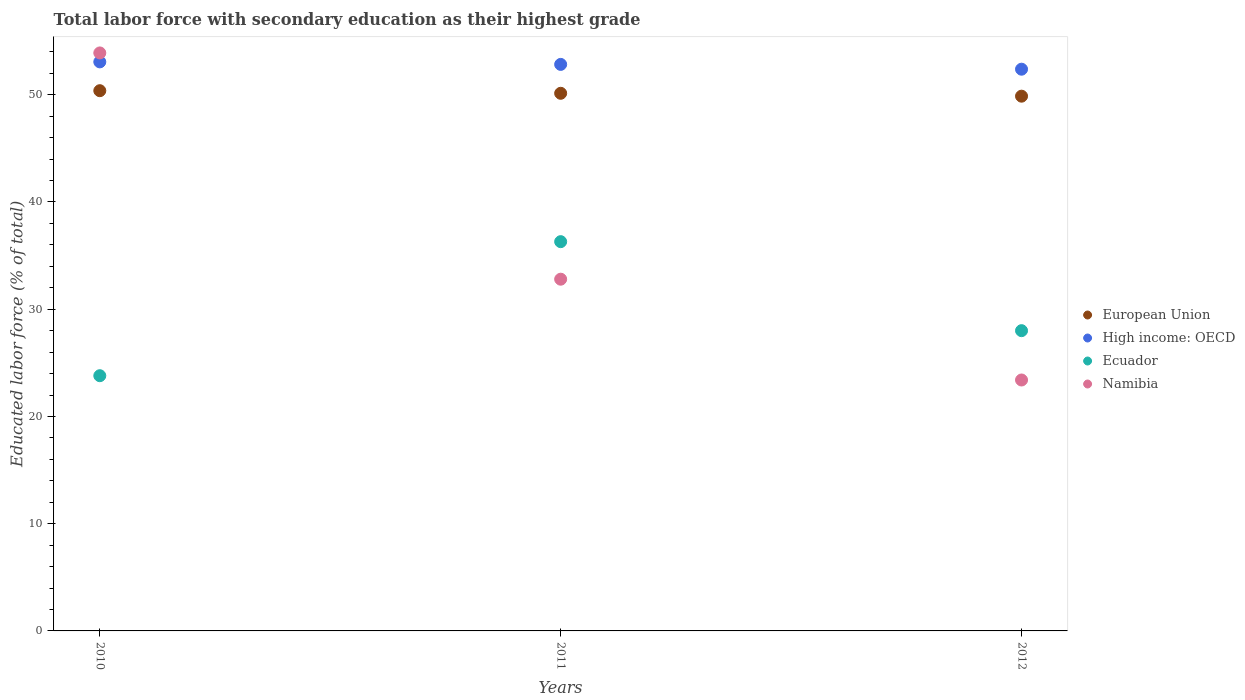Is the number of dotlines equal to the number of legend labels?
Make the answer very short. Yes. What is the percentage of total labor force with primary education in Namibia in 2011?
Provide a succinct answer. 32.8. Across all years, what is the maximum percentage of total labor force with primary education in High income: OECD?
Ensure brevity in your answer.  53.07. Across all years, what is the minimum percentage of total labor force with primary education in High income: OECD?
Your answer should be compact. 52.38. In which year was the percentage of total labor force with primary education in Namibia maximum?
Provide a succinct answer. 2010. In which year was the percentage of total labor force with primary education in High income: OECD minimum?
Your response must be concise. 2012. What is the total percentage of total labor force with primary education in High income: OECD in the graph?
Make the answer very short. 158.28. What is the difference between the percentage of total labor force with primary education in European Union in 2010 and that in 2011?
Offer a very short reply. 0.24. What is the difference between the percentage of total labor force with primary education in European Union in 2011 and the percentage of total labor force with primary education in High income: OECD in 2010?
Make the answer very short. -2.93. What is the average percentage of total labor force with primary education in Ecuador per year?
Your answer should be compact. 29.37. In the year 2012, what is the difference between the percentage of total labor force with primary education in Ecuador and percentage of total labor force with primary education in European Union?
Offer a very short reply. -21.87. In how many years, is the percentage of total labor force with primary education in Namibia greater than 2 %?
Give a very brief answer. 3. What is the ratio of the percentage of total labor force with primary education in High income: OECD in 2011 to that in 2012?
Your answer should be compact. 1.01. What is the difference between the highest and the second highest percentage of total labor force with primary education in High income: OECD?
Ensure brevity in your answer.  0.24. What is the difference between the highest and the lowest percentage of total labor force with primary education in Namibia?
Provide a succinct answer. 30.5. In how many years, is the percentage of total labor force with primary education in European Union greater than the average percentage of total labor force with primary education in European Union taken over all years?
Offer a very short reply. 2. Is the sum of the percentage of total labor force with primary education in High income: OECD in 2010 and 2011 greater than the maximum percentage of total labor force with primary education in Ecuador across all years?
Offer a terse response. Yes. Is the percentage of total labor force with primary education in High income: OECD strictly greater than the percentage of total labor force with primary education in Ecuador over the years?
Provide a short and direct response. Yes. How many dotlines are there?
Make the answer very short. 4. What is the difference between two consecutive major ticks on the Y-axis?
Give a very brief answer. 10. What is the title of the graph?
Make the answer very short. Total labor force with secondary education as their highest grade. What is the label or title of the Y-axis?
Keep it short and to the point. Educated labor force (% of total). What is the Educated labor force (% of total) in European Union in 2010?
Offer a very short reply. 50.38. What is the Educated labor force (% of total) of High income: OECD in 2010?
Provide a succinct answer. 53.07. What is the Educated labor force (% of total) in Ecuador in 2010?
Make the answer very short. 23.8. What is the Educated labor force (% of total) in Namibia in 2010?
Offer a terse response. 53.9. What is the Educated labor force (% of total) of European Union in 2011?
Keep it short and to the point. 50.14. What is the Educated labor force (% of total) in High income: OECD in 2011?
Offer a very short reply. 52.83. What is the Educated labor force (% of total) of Ecuador in 2011?
Make the answer very short. 36.3. What is the Educated labor force (% of total) of Namibia in 2011?
Your answer should be very brief. 32.8. What is the Educated labor force (% of total) of European Union in 2012?
Provide a short and direct response. 49.87. What is the Educated labor force (% of total) in High income: OECD in 2012?
Make the answer very short. 52.38. What is the Educated labor force (% of total) of Namibia in 2012?
Offer a terse response. 23.4. Across all years, what is the maximum Educated labor force (% of total) of European Union?
Make the answer very short. 50.38. Across all years, what is the maximum Educated labor force (% of total) in High income: OECD?
Make the answer very short. 53.07. Across all years, what is the maximum Educated labor force (% of total) in Ecuador?
Offer a very short reply. 36.3. Across all years, what is the maximum Educated labor force (% of total) in Namibia?
Make the answer very short. 53.9. Across all years, what is the minimum Educated labor force (% of total) of European Union?
Ensure brevity in your answer.  49.87. Across all years, what is the minimum Educated labor force (% of total) of High income: OECD?
Provide a succinct answer. 52.38. Across all years, what is the minimum Educated labor force (% of total) in Ecuador?
Your answer should be very brief. 23.8. Across all years, what is the minimum Educated labor force (% of total) in Namibia?
Make the answer very short. 23.4. What is the total Educated labor force (% of total) of European Union in the graph?
Your answer should be very brief. 150.38. What is the total Educated labor force (% of total) in High income: OECD in the graph?
Offer a terse response. 158.28. What is the total Educated labor force (% of total) in Ecuador in the graph?
Provide a succinct answer. 88.1. What is the total Educated labor force (% of total) of Namibia in the graph?
Offer a terse response. 110.1. What is the difference between the Educated labor force (% of total) in European Union in 2010 and that in 2011?
Provide a short and direct response. 0.24. What is the difference between the Educated labor force (% of total) in High income: OECD in 2010 and that in 2011?
Your answer should be compact. 0.24. What is the difference between the Educated labor force (% of total) in Namibia in 2010 and that in 2011?
Make the answer very short. 21.1. What is the difference between the Educated labor force (% of total) of European Union in 2010 and that in 2012?
Make the answer very short. 0.51. What is the difference between the Educated labor force (% of total) in High income: OECD in 2010 and that in 2012?
Your answer should be compact. 0.68. What is the difference between the Educated labor force (% of total) of Namibia in 2010 and that in 2012?
Offer a very short reply. 30.5. What is the difference between the Educated labor force (% of total) of European Union in 2011 and that in 2012?
Your response must be concise. 0.27. What is the difference between the Educated labor force (% of total) in High income: OECD in 2011 and that in 2012?
Your answer should be compact. 0.45. What is the difference between the Educated labor force (% of total) of Ecuador in 2011 and that in 2012?
Ensure brevity in your answer.  8.3. What is the difference between the Educated labor force (% of total) of Namibia in 2011 and that in 2012?
Ensure brevity in your answer.  9.4. What is the difference between the Educated labor force (% of total) of European Union in 2010 and the Educated labor force (% of total) of High income: OECD in 2011?
Keep it short and to the point. -2.45. What is the difference between the Educated labor force (% of total) in European Union in 2010 and the Educated labor force (% of total) in Ecuador in 2011?
Your answer should be very brief. 14.08. What is the difference between the Educated labor force (% of total) in European Union in 2010 and the Educated labor force (% of total) in Namibia in 2011?
Offer a very short reply. 17.58. What is the difference between the Educated labor force (% of total) of High income: OECD in 2010 and the Educated labor force (% of total) of Ecuador in 2011?
Keep it short and to the point. 16.77. What is the difference between the Educated labor force (% of total) in High income: OECD in 2010 and the Educated labor force (% of total) in Namibia in 2011?
Your response must be concise. 20.27. What is the difference between the Educated labor force (% of total) of European Union in 2010 and the Educated labor force (% of total) of High income: OECD in 2012?
Give a very brief answer. -2. What is the difference between the Educated labor force (% of total) of European Union in 2010 and the Educated labor force (% of total) of Ecuador in 2012?
Your response must be concise. 22.38. What is the difference between the Educated labor force (% of total) of European Union in 2010 and the Educated labor force (% of total) of Namibia in 2012?
Provide a short and direct response. 26.98. What is the difference between the Educated labor force (% of total) of High income: OECD in 2010 and the Educated labor force (% of total) of Ecuador in 2012?
Your answer should be compact. 25.07. What is the difference between the Educated labor force (% of total) in High income: OECD in 2010 and the Educated labor force (% of total) in Namibia in 2012?
Ensure brevity in your answer.  29.67. What is the difference between the Educated labor force (% of total) of European Union in 2011 and the Educated labor force (% of total) of High income: OECD in 2012?
Offer a terse response. -2.25. What is the difference between the Educated labor force (% of total) in European Union in 2011 and the Educated labor force (% of total) in Ecuador in 2012?
Keep it short and to the point. 22.14. What is the difference between the Educated labor force (% of total) of European Union in 2011 and the Educated labor force (% of total) of Namibia in 2012?
Offer a terse response. 26.74. What is the difference between the Educated labor force (% of total) in High income: OECD in 2011 and the Educated labor force (% of total) in Ecuador in 2012?
Your answer should be very brief. 24.83. What is the difference between the Educated labor force (% of total) of High income: OECD in 2011 and the Educated labor force (% of total) of Namibia in 2012?
Your response must be concise. 29.43. What is the average Educated labor force (% of total) in European Union per year?
Your answer should be very brief. 50.13. What is the average Educated labor force (% of total) in High income: OECD per year?
Your response must be concise. 52.76. What is the average Educated labor force (% of total) of Ecuador per year?
Provide a short and direct response. 29.37. What is the average Educated labor force (% of total) of Namibia per year?
Keep it short and to the point. 36.7. In the year 2010, what is the difference between the Educated labor force (% of total) in European Union and Educated labor force (% of total) in High income: OECD?
Your response must be concise. -2.69. In the year 2010, what is the difference between the Educated labor force (% of total) of European Union and Educated labor force (% of total) of Ecuador?
Keep it short and to the point. 26.58. In the year 2010, what is the difference between the Educated labor force (% of total) in European Union and Educated labor force (% of total) in Namibia?
Offer a very short reply. -3.52. In the year 2010, what is the difference between the Educated labor force (% of total) of High income: OECD and Educated labor force (% of total) of Ecuador?
Make the answer very short. 29.27. In the year 2010, what is the difference between the Educated labor force (% of total) in High income: OECD and Educated labor force (% of total) in Namibia?
Keep it short and to the point. -0.83. In the year 2010, what is the difference between the Educated labor force (% of total) of Ecuador and Educated labor force (% of total) of Namibia?
Ensure brevity in your answer.  -30.1. In the year 2011, what is the difference between the Educated labor force (% of total) of European Union and Educated labor force (% of total) of High income: OECD?
Offer a very short reply. -2.69. In the year 2011, what is the difference between the Educated labor force (% of total) in European Union and Educated labor force (% of total) in Ecuador?
Provide a succinct answer. 13.84. In the year 2011, what is the difference between the Educated labor force (% of total) in European Union and Educated labor force (% of total) in Namibia?
Provide a succinct answer. 17.34. In the year 2011, what is the difference between the Educated labor force (% of total) of High income: OECD and Educated labor force (% of total) of Ecuador?
Provide a short and direct response. 16.53. In the year 2011, what is the difference between the Educated labor force (% of total) of High income: OECD and Educated labor force (% of total) of Namibia?
Make the answer very short. 20.03. In the year 2011, what is the difference between the Educated labor force (% of total) in Ecuador and Educated labor force (% of total) in Namibia?
Offer a very short reply. 3.5. In the year 2012, what is the difference between the Educated labor force (% of total) in European Union and Educated labor force (% of total) in High income: OECD?
Offer a terse response. -2.52. In the year 2012, what is the difference between the Educated labor force (% of total) in European Union and Educated labor force (% of total) in Ecuador?
Your answer should be compact. 21.87. In the year 2012, what is the difference between the Educated labor force (% of total) of European Union and Educated labor force (% of total) of Namibia?
Your answer should be compact. 26.47. In the year 2012, what is the difference between the Educated labor force (% of total) of High income: OECD and Educated labor force (% of total) of Ecuador?
Give a very brief answer. 24.38. In the year 2012, what is the difference between the Educated labor force (% of total) of High income: OECD and Educated labor force (% of total) of Namibia?
Your response must be concise. 28.98. In the year 2012, what is the difference between the Educated labor force (% of total) of Ecuador and Educated labor force (% of total) of Namibia?
Your answer should be compact. 4.6. What is the ratio of the Educated labor force (% of total) of European Union in 2010 to that in 2011?
Offer a very short reply. 1. What is the ratio of the Educated labor force (% of total) of Ecuador in 2010 to that in 2011?
Your answer should be very brief. 0.66. What is the ratio of the Educated labor force (% of total) in Namibia in 2010 to that in 2011?
Your answer should be very brief. 1.64. What is the ratio of the Educated labor force (% of total) of European Union in 2010 to that in 2012?
Provide a short and direct response. 1.01. What is the ratio of the Educated labor force (% of total) of Ecuador in 2010 to that in 2012?
Your answer should be very brief. 0.85. What is the ratio of the Educated labor force (% of total) of Namibia in 2010 to that in 2012?
Your answer should be very brief. 2.3. What is the ratio of the Educated labor force (% of total) of European Union in 2011 to that in 2012?
Make the answer very short. 1.01. What is the ratio of the Educated labor force (% of total) of High income: OECD in 2011 to that in 2012?
Your answer should be compact. 1.01. What is the ratio of the Educated labor force (% of total) in Ecuador in 2011 to that in 2012?
Offer a terse response. 1.3. What is the ratio of the Educated labor force (% of total) in Namibia in 2011 to that in 2012?
Offer a very short reply. 1.4. What is the difference between the highest and the second highest Educated labor force (% of total) of European Union?
Give a very brief answer. 0.24. What is the difference between the highest and the second highest Educated labor force (% of total) in High income: OECD?
Your answer should be compact. 0.24. What is the difference between the highest and the second highest Educated labor force (% of total) of Namibia?
Offer a terse response. 21.1. What is the difference between the highest and the lowest Educated labor force (% of total) of European Union?
Keep it short and to the point. 0.51. What is the difference between the highest and the lowest Educated labor force (% of total) of High income: OECD?
Offer a terse response. 0.68. What is the difference between the highest and the lowest Educated labor force (% of total) in Namibia?
Your answer should be compact. 30.5. 